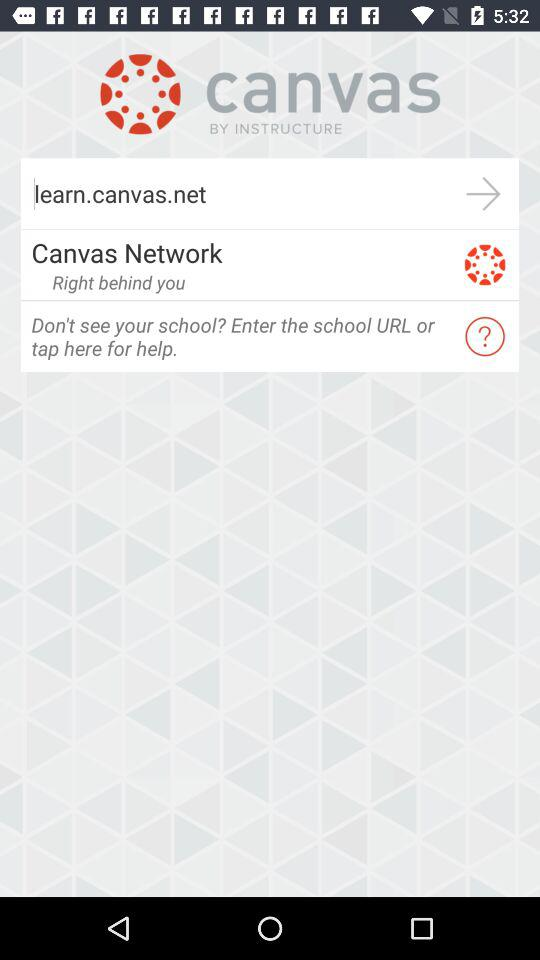What is the app name? The app name is "canvas". 